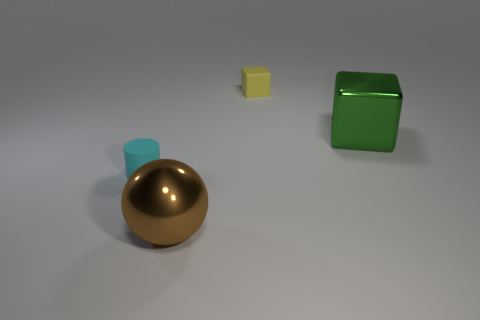Are there any other things that are the same shape as the large brown thing?
Offer a terse response. No. How many blocks are tiny green things or cyan rubber objects?
Your answer should be compact. 0. There is a thing that is on the left side of the tiny yellow rubber thing and behind the brown metal ball; what is its shape?
Provide a succinct answer. Cylinder. Is the number of big green metallic things that are left of the yellow block the same as the number of small rubber things that are behind the matte cylinder?
Provide a succinct answer. No. What number of things are either brown objects or big blue cubes?
Provide a short and direct response. 1. The other object that is the same size as the yellow matte thing is what color?
Your response must be concise. Cyan. How many things are either big metallic things that are right of the tiny yellow matte object or tiny matte things behind the tiny cylinder?
Provide a succinct answer. 2. Is the number of large brown shiny balls that are behind the tiny cyan matte cylinder the same as the number of tiny red cylinders?
Offer a terse response. Yes. Does the metallic thing that is behind the large ball have the same size as the matte thing on the right side of the big brown shiny object?
Make the answer very short. No. What number of other objects are there of the same size as the yellow rubber block?
Provide a succinct answer. 1. 